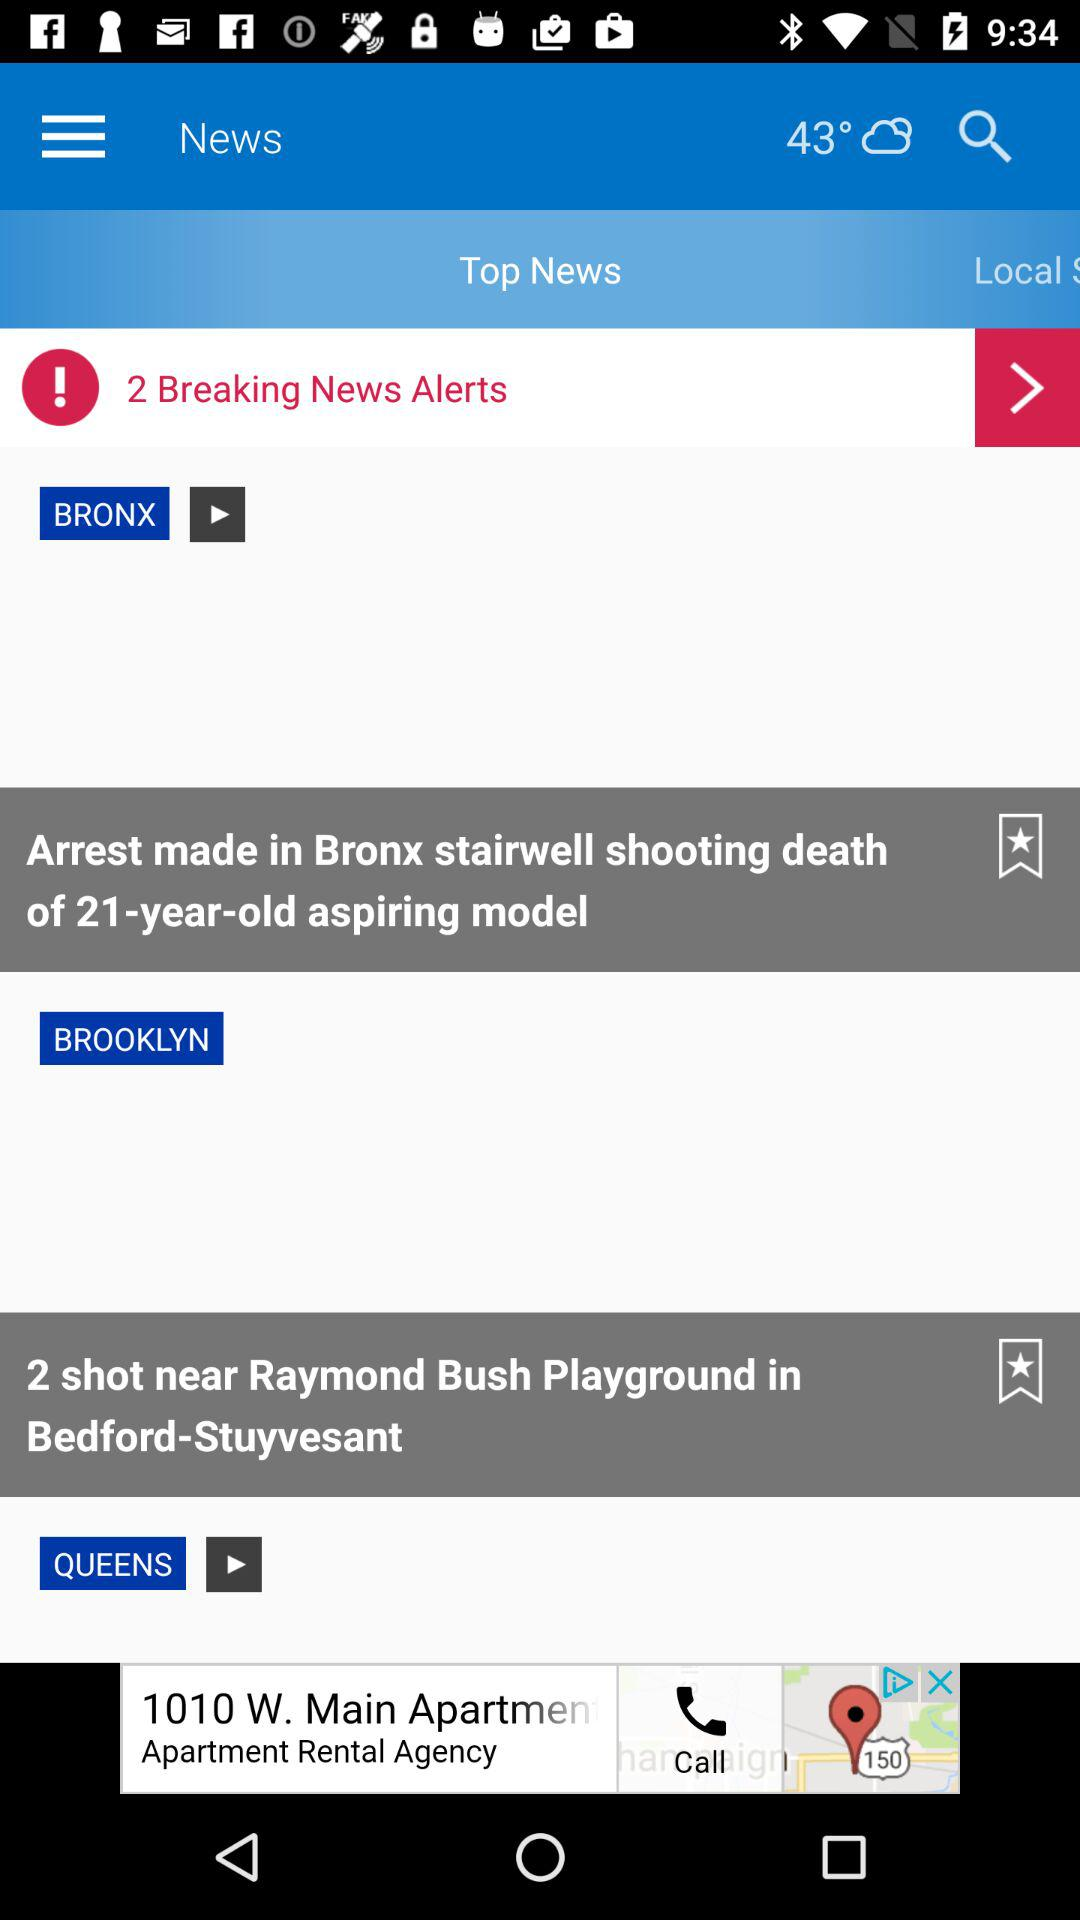How many breaking news alerts are there? There are 2 breaking news alerts. 